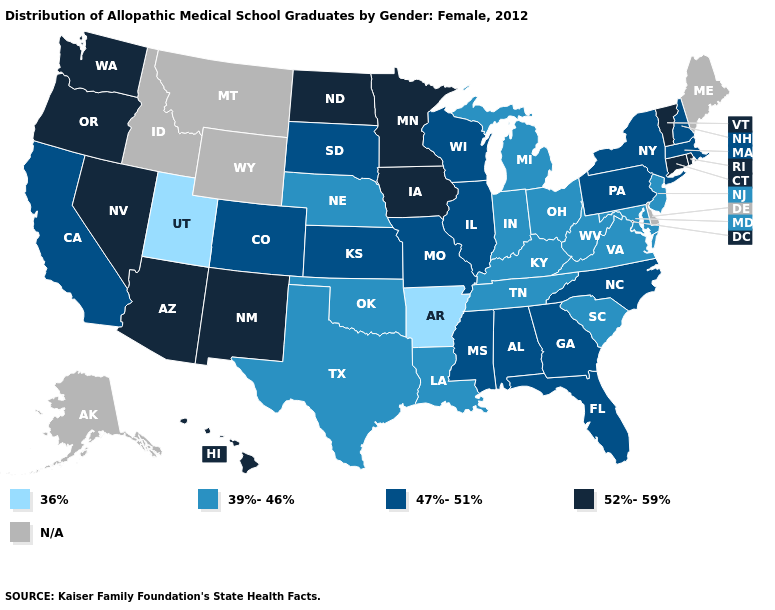What is the value of Kansas?
Quick response, please. 47%-51%. Name the states that have a value in the range 52%-59%?
Answer briefly. Arizona, Connecticut, Hawaii, Iowa, Minnesota, Nevada, New Mexico, North Dakota, Oregon, Rhode Island, Vermont, Washington. What is the highest value in the USA?
Answer briefly. 52%-59%. Name the states that have a value in the range 39%-46%?
Concise answer only. Indiana, Kentucky, Louisiana, Maryland, Michigan, Nebraska, New Jersey, Ohio, Oklahoma, South Carolina, Tennessee, Texas, Virginia, West Virginia. What is the value of Colorado?
Answer briefly. 47%-51%. Name the states that have a value in the range 39%-46%?
Short answer required. Indiana, Kentucky, Louisiana, Maryland, Michigan, Nebraska, New Jersey, Ohio, Oklahoma, South Carolina, Tennessee, Texas, Virginia, West Virginia. What is the value of Massachusetts?
Keep it brief. 47%-51%. Name the states that have a value in the range 39%-46%?
Short answer required. Indiana, Kentucky, Louisiana, Maryland, Michigan, Nebraska, New Jersey, Ohio, Oklahoma, South Carolina, Tennessee, Texas, Virginia, West Virginia. Which states have the lowest value in the USA?
Concise answer only. Arkansas, Utah. What is the value of Delaware?
Keep it brief. N/A. Which states hav the highest value in the Northeast?
Quick response, please. Connecticut, Rhode Island, Vermont. What is the value of Arizona?
Keep it brief. 52%-59%. What is the value of Maine?
Be succinct. N/A. Name the states that have a value in the range N/A?
Quick response, please. Alaska, Delaware, Idaho, Maine, Montana, Wyoming. What is the lowest value in states that border West Virginia?
Answer briefly. 39%-46%. 